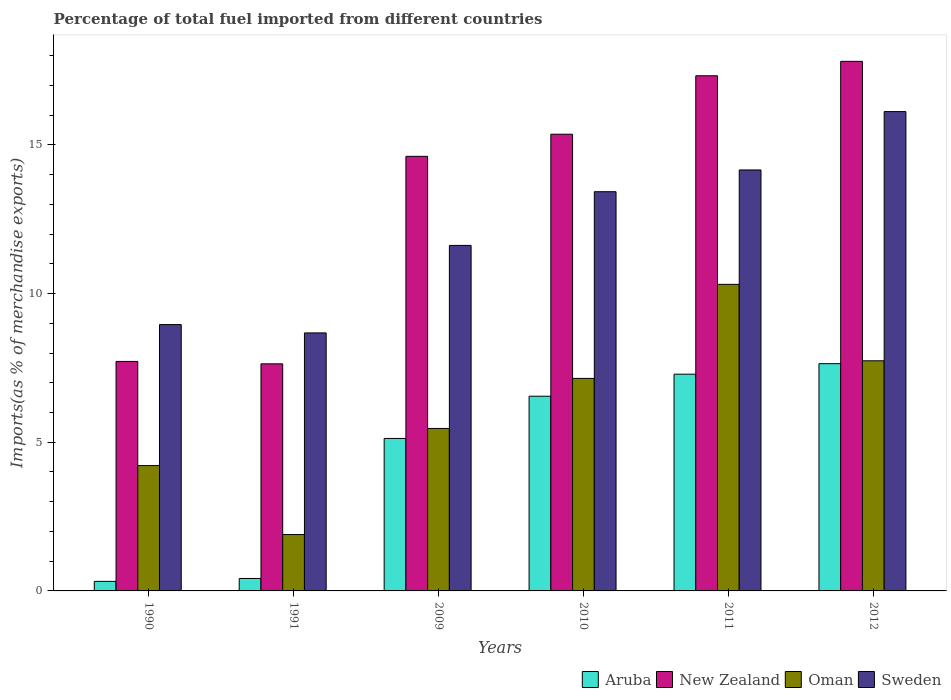Are the number of bars on each tick of the X-axis equal?
Your answer should be compact. Yes. What is the percentage of imports to different countries in Aruba in 1990?
Provide a short and direct response. 0.32. Across all years, what is the maximum percentage of imports to different countries in Sweden?
Give a very brief answer. 16.12. Across all years, what is the minimum percentage of imports to different countries in Oman?
Make the answer very short. 1.9. In which year was the percentage of imports to different countries in Oman maximum?
Provide a succinct answer. 2011. In which year was the percentage of imports to different countries in Oman minimum?
Provide a short and direct response. 1991. What is the total percentage of imports to different countries in Sweden in the graph?
Offer a very short reply. 72.95. What is the difference between the percentage of imports to different countries in Aruba in 1990 and that in 2009?
Your answer should be compact. -4.81. What is the difference between the percentage of imports to different countries in New Zealand in 2011 and the percentage of imports to different countries in Oman in 2010?
Offer a very short reply. 10.18. What is the average percentage of imports to different countries in Sweden per year?
Offer a very short reply. 12.16. In the year 2010, what is the difference between the percentage of imports to different countries in New Zealand and percentage of imports to different countries in Sweden?
Give a very brief answer. 1.93. In how many years, is the percentage of imports to different countries in Aruba greater than 5 %?
Provide a succinct answer. 4. What is the ratio of the percentage of imports to different countries in New Zealand in 1991 to that in 2009?
Your answer should be compact. 0.52. Is the percentage of imports to different countries in Oman in 1990 less than that in 2012?
Provide a succinct answer. Yes. Is the difference between the percentage of imports to different countries in New Zealand in 1990 and 2010 greater than the difference between the percentage of imports to different countries in Sweden in 1990 and 2010?
Your answer should be compact. No. What is the difference between the highest and the second highest percentage of imports to different countries in Oman?
Offer a very short reply. 2.57. What is the difference between the highest and the lowest percentage of imports to different countries in Oman?
Provide a short and direct response. 8.41. In how many years, is the percentage of imports to different countries in Aruba greater than the average percentage of imports to different countries in Aruba taken over all years?
Your answer should be very brief. 4. Is the sum of the percentage of imports to different countries in New Zealand in 2009 and 2010 greater than the maximum percentage of imports to different countries in Oman across all years?
Make the answer very short. Yes. Is it the case that in every year, the sum of the percentage of imports to different countries in New Zealand and percentage of imports to different countries in Aruba is greater than the sum of percentage of imports to different countries in Sweden and percentage of imports to different countries in Oman?
Ensure brevity in your answer.  No. What does the 4th bar from the left in 2011 represents?
Keep it short and to the point. Sweden. What does the 2nd bar from the right in 2010 represents?
Ensure brevity in your answer.  Oman. Are all the bars in the graph horizontal?
Offer a terse response. No. What is the difference between two consecutive major ticks on the Y-axis?
Make the answer very short. 5. Does the graph contain grids?
Ensure brevity in your answer.  No. What is the title of the graph?
Keep it short and to the point. Percentage of total fuel imported from different countries. What is the label or title of the Y-axis?
Your answer should be very brief. Imports(as % of merchandise exports). What is the Imports(as % of merchandise exports) in Aruba in 1990?
Offer a terse response. 0.32. What is the Imports(as % of merchandise exports) in New Zealand in 1990?
Provide a short and direct response. 7.72. What is the Imports(as % of merchandise exports) of Oman in 1990?
Give a very brief answer. 4.21. What is the Imports(as % of merchandise exports) of Sweden in 1990?
Make the answer very short. 8.96. What is the Imports(as % of merchandise exports) of Aruba in 1991?
Offer a terse response. 0.42. What is the Imports(as % of merchandise exports) of New Zealand in 1991?
Give a very brief answer. 7.64. What is the Imports(as % of merchandise exports) in Oman in 1991?
Your response must be concise. 1.9. What is the Imports(as % of merchandise exports) of Sweden in 1991?
Make the answer very short. 8.68. What is the Imports(as % of merchandise exports) of Aruba in 2009?
Your answer should be very brief. 5.13. What is the Imports(as % of merchandise exports) of New Zealand in 2009?
Keep it short and to the point. 14.61. What is the Imports(as % of merchandise exports) of Oman in 2009?
Your answer should be compact. 5.46. What is the Imports(as % of merchandise exports) of Sweden in 2009?
Ensure brevity in your answer.  11.62. What is the Imports(as % of merchandise exports) of Aruba in 2010?
Give a very brief answer. 6.55. What is the Imports(as % of merchandise exports) of New Zealand in 2010?
Your answer should be compact. 15.36. What is the Imports(as % of merchandise exports) of Oman in 2010?
Provide a short and direct response. 7.15. What is the Imports(as % of merchandise exports) of Sweden in 2010?
Ensure brevity in your answer.  13.42. What is the Imports(as % of merchandise exports) in Aruba in 2011?
Provide a succinct answer. 7.29. What is the Imports(as % of merchandise exports) of New Zealand in 2011?
Make the answer very short. 17.32. What is the Imports(as % of merchandise exports) of Oman in 2011?
Offer a terse response. 10.31. What is the Imports(as % of merchandise exports) in Sweden in 2011?
Your answer should be compact. 14.16. What is the Imports(as % of merchandise exports) in Aruba in 2012?
Ensure brevity in your answer.  7.64. What is the Imports(as % of merchandise exports) in New Zealand in 2012?
Offer a very short reply. 17.81. What is the Imports(as % of merchandise exports) of Oman in 2012?
Your answer should be very brief. 7.74. What is the Imports(as % of merchandise exports) of Sweden in 2012?
Provide a succinct answer. 16.12. Across all years, what is the maximum Imports(as % of merchandise exports) in Aruba?
Offer a very short reply. 7.64. Across all years, what is the maximum Imports(as % of merchandise exports) in New Zealand?
Ensure brevity in your answer.  17.81. Across all years, what is the maximum Imports(as % of merchandise exports) in Oman?
Offer a very short reply. 10.31. Across all years, what is the maximum Imports(as % of merchandise exports) of Sweden?
Ensure brevity in your answer.  16.12. Across all years, what is the minimum Imports(as % of merchandise exports) in Aruba?
Keep it short and to the point. 0.32. Across all years, what is the minimum Imports(as % of merchandise exports) in New Zealand?
Your answer should be compact. 7.64. Across all years, what is the minimum Imports(as % of merchandise exports) in Oman?
Offer a terse response. 1.9. Across all years, what is the minimum Imports(as % of merchandise exports) of Sweden?
Keep it short and to the point. 8.68. What is the total Imports(as % of merchandise exports) in Aruba in the graph?
Your response must be concise. 27.35. What is the total Imports(as % of merchandise exports) in New Zealand in the graph?
Offer a very short reply. 80.46. What is the total Imports(as % of merchandise exports) of Oman in the graph?
Keep it short and to the point. 36.77. What is the total Imports(as % of merchandise exports) of Sweden in the graph?
Your response must be concise. 72.95. What is the difference between the Imports(as % of merchandise exports) of Aruba in 1990 and that in 1991?
Provide a short and direct response. -0.1. What is the difference between the Imports(as % of merchandise exports) in New Zealand in 1990 and that in 1991?
Make the answer very short. 0.08. What is the difference between the Imports(as % of merchandise exports) of Oman in 1990 and that in 1991?
Offer a very short reply. 2.32. What is the difference between the Imports(as % of merchandise exports) in Sweden in 1990 and that in 1991?
Your response must be concise. 0.28. What is the difference between the Imports(as % of merchandise exports) in Aruba in 1990 and that in 2009?
Make the answer very short. -4.81. What is the difference between the Imports(as % of merchandise exports) in New Zealand in 1990 and that in 2009?
Offer a very short reply. -6.9. What is the difference between the Imports(as % of merchandise exports) of Oman in 1990 and that in 2009?
Ensure brevity in your answer.  -1.25. What is the difference between the Imports(as % of merchandise exports) in Sweden in 1990 and that in 2009?
Offer a terse response. -2.66. What is the difference between the Imports(as % of merchandise exports) of Aruba in 1990 and that in 2010?
Provide a succinct answer. -6.23. What is the difference between the Imports(as % of merchandise exports) in New Zealand in 1990 and that in 2010?
Offer a terse response. -7.64. What is the difference between the Imports(as % of merchandise exports) of Oman in 1990 and that in 2010?
Offer a terse response. -2.93. What is the difference between the Imports(as % of merchandise exports) of Sweden in 1990 and that in 2010?
Give a very brief answer. -4.47. What is the difference between the Imports(as % of merchandise exports) of Aruba in 1990 and that in 2011?
Provide a succinct answer. -6.97. What is the difference between the Imports(as % of merchandise exports) of New Zealand in 1990 and that in 2011?
Keep it short and to the point. -9.61. What is the difference between the Imports(as % of merchandise exports) of Oman in 1990 and that in 2011?
Your answer should be compact. -6.09. What is the difference between the Imports(as % of merchandise exports) in Sweden in 1990 and that in 2011?
Keep it short and to the point. -5.2. What is the difference between the Imports(as % of merchandise exports) of Aruba in 1990 and that in 2012?
Keep it short and to the point. -7.32. What is the difference between the Imports(as % of merchandise exports) of New Zealand in 1990 and that in 2012?
Keep it short and to the point. -10.09. What is the difference between the Imports(as % of merchandise exports) in Oman in 1990 and that in 2012?
Your answer should be compact. -3.52. What is the difference between the Imports(as % of merchandise exports) in Sweden in 1990 and that in 2012?
Give a very brief answer. -7.16. What is the difference between the Imports(as % of merchandise exports) in Aruba in 1991 and that in 2009?
Offer a terse response. -4.71. What is the difference between the Imports(as % of merchandise exports) of New Zealand in 1991 and that in 2009?
Provide a short and direct response. -6.98. What is the difference between the Imports(as % of merchandise exports) in Oman in 1991 and that in 2009?
Your answer should be compact. -3.57. What is the difference between the Imports(as % of merchandise exports) of Sweden in 1991 and that in 2009?
Provide a short and direct response. -2.94. What is the difference between the Imports(as % of merchandise exports) in Aruba in 1991 and that in 2010?
Make the answer very short. -6.13. What is the difference between the Imports(as % of merchandise exports) in New Zealand in 1991 and that in 2010?
Offer a very short reply. -7.72. What is the difference between the Imports(as % of merchandise exports) of Oman in 1991 and that in 2010?
Make the answer very short. -5.25. What is the difference between the Imports(as % of merchandise exports) in Sweden in 1991 and that in 2010?
Offer a terse response. -4.75. What is the difference between the Imports(as % of merchandise exports) in Aruba in 1991 and that in 2011?
Your response must be concise. -6.87. What is the difference between the Imports(as % of merchandise exports) in New Zealand in 1991 and that in 2011?
Offer a terse response. -9.69. What is the difference between the Imports(as % of merchandise exports) of Oman in 1991 and that in 2011?
Your answer should be compact. -8.41. What is the difference between the Imports(as % of merchandise exports) in Sweden in 1991 and that in 2011?
Give a very brief answer. -5.48. What is the difference between the Imports(as % of merchandise exports) in Aruba in 1991 and that in 2012?
Offer a very short reply. -7.22. What is the difference between the Imports(as % of merchandise exports) of New Zealand in 1991 and that in 2012?
Keep it short and to the point. -10.17. What is the difference between the Imports(as % of merchandise exports) of Oman in 1991 and that in 2012?
Your answer should be very brief. -5.84. What is the difference between the Imports(as % of merchandise exports) in Sweden in 1991 and that in 2012?
Offer a very short reply. -7.44. What is the difference between the Imports(as % of merchandise exports) in Aruba in 2009 and that in 2010?
Keep it short and to the point. -1.42. What is the difference between the Imports(as % of merchandise exports) in New Zealand in 2009 and that in 2010?
Your answer should be very brief. -0.74. What is the difference between the Imports(as % of merchandise exports) of Oman in 2009 and that in 2010?
Your answer should be compact. -1.68. What is the difference between the Imports(as % of merchandise exports) in Sweden in 2009 and that in 2010?
Keep it short and to the point. -1.81. What is the difference between the Imports(as % of merchandise exports) in Aruba in 2009 and that in 2011?
Ensure brevity in your answer.  -2.16. What is the difference between the Imports(as % of merchandise exports) of New Zealand in 2009 and that in 2011?
Provide a short and direct response. -2.71. What is the difference between the Imports(as % of merchandise exports) of Oman in 2009 and that in 2011?
Give a very brief answer. -4.85. What is the difference between the Imports(as % of merchandise exports) of Sweden in 2009 and that in 2011?
Ensure brevity in your answer.  -2.54. What is the difference between the Imports(as % of merchandise exports) of Aruba in 2009 and that in 2012?
Your answer should be very brief. -2.51. What is the difference between the Imports(as % of merchandise exports) in New Zealand in 2009 and that in 2012?
Give a very brief answer. -3.19. What is the difference between the Imports(as % of merchandise exports) of Oman in 2009 and that in 2012?
Offer a very short reply. -2.28. What is the difference between the Imports(as % of merchandise exports) in Sweden in 2009 and that in 2012?
Provide a short and direct response. -4.5. What is the difference between the Imports(as % of merchandise exports) in Aruba in 2010 and that in 2011?
Give a very brief answer. -0.74. What is the difference between the Imports(as % of merchandise exports) of New Zealand in 2010 and that in 2011?
Your response must be concise. -1.97. What is the difference between the Imports(as % of merchandise exports) of Oman in 2010 and that in 2011?
Your answer should be very brief. -3.16. What is the difference between the Imports(as % of merchandise exports) in Sweden in 2010 and that in 2011?
Provide a short and direct response. -0.73. What is the difference between the Imports(as % of merchandise exports) in Aruba in 2010 and that in 2012?
Keep it short and to the point. -1.09. What is the difference between the Imports(as % of merchandise exports) in New Zealand in 2010 and that in 2012?
Ensure brevity in your answer.  -2.45. What is the difference between the Imports(as % of merchandise exports) of Oman in 2010 and that in 2012?
Ensure brevity in your answer.  -0.59. What is the difference between the Imports(as % of merchandise exports) in Sweden in 2010 and that in 2012?
Your answer should be compact. -2.69. What is the difference between the Imports(as % of merchandise exports) in Aruba in 2011 and that in 2012?
Provide a short and direct response. -0.35. What is the difference between the Imports(as % of merchandise exports) of New Zealand in 2011 and that in 2012?
Offer a very short reply. -0.48. What is the difference between the Imports(as % of merchandise exports) of Oman in 2011 and that in 2012?
Your response must be concise. 2.57. What is the difference between the Imports(as % of merchandise exports) of Sweden in 2011 and that in 2012?
Provide a succinct answer. -1.96. What is the difference between the Imports(as % of merchandise exports) in Aruba in 1990 and the Imports(as % of merchandise exports) in New Zealand in 1991?
Your answer should be compact. -7.31. What is the difference between the Imports(as % of merchandise exports) in Aruba in 1990 and the Imports(as % of merchandise exports) in Oman in 1991?
Offer a very short reply. -1.57. What is the difference between the Imports(as % of merchandise exports) in Aruba in 1990 and the Imports(as % of merchandise exports) in Sweden in 1991?
Provide a short and direct response. -8.35. What is the difference between the Imports(as % of merchandise exports) of New Zealand in 1990 and the Imports(as % of merchandise exports) of Oman in 1991?
Your response must be concise. 5.82. What is the difference between the Imports(as % of merchandise exports) in New Zealand in 1990 and the Imports(as % of merchandise exports) in Sweden in 1991?
Your response must be concise. -0.96. What is the difference between the Imports(as % of merchandise exports) of Oman in 1990 and the Imports(as % of merchandise exports) of Sweden in 1991?
Ensure brevity in your answer.  -4.46. What is the difference between the Imports(as % of merchandise exports) in Aruba in 1990 and the Imports(as % of merchandise exports) in New Zealand in 2009?
Keep it short and to the point. -14.29. What is the difference between the Imports(as % of merchandise exports) in Aruba in 1990 and the Imports(as % of merchandise exports) in Oman in 2009?
Your answer should be compact. -5.14. What is the difference between the Imports(as % of merchandise exports) of Aruba in 1990 and the Imports(as % of merchandise exports) of Sweden in 2009?
Provide a succinct answer. -11.3. What is the difference between the Imports(as % of merchandise exports) in New Zealand in 1990 and the Imports(as % of merchandise exports) in Oman in 2009?
Provide a succinct answer. 2.25. What is the difference between the Imports(as % of merchandise exports) in New Zealand in 1990 and the Imports(as % of merchandise exports) in Sweden in 2009?
Provide a short and direct response. -3.9. What is the difference between the Imports(as % of merchandise exports) in Oman in 1990 and the Imports(as % of merchandise exports) in Sweden in 2009?
Ensure brevity in your answer.  -7.4. What is the difference between the Imports(as % of merchandise exports) of Aruba in 1990 and the Imports(as % of merchandise exports) of New Zealand in 2010?
Offer a terse response. -15.04. What is the difference between the Imports(as % of merchandise exports) of Aruba in 1990 and the Imports(as % of merchandise exports) of Oman in 2010?
Provide a succinct answer. -6.82. What is the difference between the Imports(as % of merchandise exports) of Aruba in 1990 and the Imports(as % of merchandise exports) of Sweden in 2010?
Your answer should be compact. -13.1. What is the difference between the Imports(as % of merchandise exports) of New Zealand in 1990 and the Imports(as % of merchandise exports) of Oman in 2010?
Keep it short and to the point. 0.57. What is the difference between the Imports(as % of merchandise exports) of New Zealand in 1990 and the Imports(as % of merchandise exports) of Sweden in 2010?
Give a very brief answer. -5.71. What is the difference between the Imports(as % of merchandise exports) of Oman in 1990 and the Imports(as % of merchandise exports) of Sweden in 2010?
Offer a terse response. -9.21. What is the difference between the Imports(as % of merchandise exports) of Aruba in 1990 and the Imports(as % of merchandise exports) of New Zealand in 2011?
Ensure brevity in your answer.  -17. What is the difference between the Imports(as % of merchandise exports) of Aruba in 1990 and the Imports(as % of merchandise exports) of Oman in 2011?
Keep it short and to the point. -9.99. What is the difference between the Imports(as % of merchandise exports) in Aruba in 1990 and the Imports(as % of merchandise exports) in Sweden in 2011?
Provide a short and direct response. -13.83. What is the difference between the Imports(as % of merchandise exports) of New Zealand in 1990 and the Imports(as % of merchandise exports) of Oman in 2011?
Keep it short and to the point. -2.59. What is the difference between the Imports(as % of merchandise exports) in New Zealand in 1990 and the Imports(as % of merchandise exports) in Sweden in 2011?
Ensure brevity in your answer.  -6.44. What is the difference between the Imports(as % of merchandise exports) in Oman in 1990 and the Imports(as % of merchandise exports) in Sweden in 2011?
Your answer should be compact. -9.94. What is the difference between the Imports(as % of merchandise exports) of Aruba in 1990 and the Imports(as % of merchandise exports) of New Zealand in 2012?
Give a very brief answer. -17.49. What is the difference between the Imports(as % of merchandise exports) of Aruba in 1990 and the Imports(as % of merchandise exports) of Oman in 2012?
Ensure brevity in your answer.  -7.42. What is the difference between the Imports(as % of merchandise exports) in Aruba in 1990 and the Imports(as % of merchandise exports) in Sweden in 2012?
Keep it short and to the point. -15.8. What is the difference between the Imports(as % of merchandise exports) in New Zealand in 1990 and the Imports(as % of merchandise exports) in Oman in 2012?
Provide a short and direct response. -0.02. What is the difference between the Imports(as % of merchandise exports) in New Zealand in 1990 and the Imports(as % of merchandise exports) in Sweden in 2012?
Offer a very short reply. -8.4. What is the difference between the Imports(as % of merchandise exports) in Oman in 1990 and the Imports(as % of merchandise exports) in Sweden in 2012?
Your response must be concise. -11.9. What is the difference between the Imports(as % of merchandise exports) in Aruba in 1991 and the Imports(as % of merchandise exports) in New Zealand in 2009?
Your response must be concise. -14.2. What is the difference between the Imports(as % of merchandise exports) of Aruba in 1991 and the Imports(as % of merchandise exports) of Oman in 2009?
Ensure brevity in your answer.  -5.04. What is the difference between the Imports(as % of merchandise exports) of Aruba in 1991 and the Imports(as % of merchandise exports) of Sweden in 2009?
Your answer should be compact. -11.2. What is the difference between the Imports(as % of merchandise exports) in New Zealand in 1991 and the Imports(as % of merchandise exports) in Oman in 2009?
Your response must be concise. 2.17. What is the difference between the Imports(as % of merchandise exports) in New Zealand in 1991 and the Imports(as % of merchandise exports) in Sweden in 2009?
Ensure brevity in your answer.  -3.98. What is the difference between the Imports(as % of merchandise exports) of Oman in 1991 and the Imports(as % of merchandise exports) of Sweden in 2009?
Provide a short and direct response. -9.72. What is the difference between the Imports(as % of merchandise exports) in Aruba in 1991 and the Imports(as % of merchandise exports) in New Zealand in 2010?
Provide a short and direct response. -14.94. What is the difference between the Imports(as % of merchandise exports) of Aruba in 1991 and the Imports(as % of merchandise exports) of Oman in 2010?
Provide a short and direct response. -6.73. What is the difference between the Imports(as % of merchandise exports) of Aruba in 1991 and the Imports(as % of merchandise exports) of Sweden in 2010?
Your answer should be very brief. -13.01. What is the difference between the Imports(as % of merchandise exports) in New Zealand in 1991 and the Imports(as % of merchandise exports) in Oman in 2010?
Offer a very short reply. 0.49. What is the difference between the Imports(as % of merchandise exports) of New Zealand in 1991 and the Imports(as % of merchandise exports) of Sweden in 2010?
Make the answer very short. -5.79. What is the difference between the Imports(as % of merchandise exports) in Oman in 1991 and the Imports(as % of merchandise exports) in Sweden in 2010?
Your response must be concise. -11.53. What is the difference between the Imports(as % of merchandise exports) in Aruba in 1991 and the Imports(as % of merchandise exports) in New Zealand in 2011?
Ensure brevity in your answer.  -16.9. What is the difference between the Imports(as % of merchandise exports) in Aruba in 1991 and the Imports(as % of merchandise exports) in Oman in 2011?
Provide a short and direct response. -9.89. What is the difference between the Imports(as % of merchandise exports) in Aruba in 1991 and the Imports(as % of merchandise exports) in Sweden in 2011?
Make the answer very short. -13.74. What is the difference between the Imports(as % of merchandise exports) in New Zealand in 1991 and the Imports(as % of merchandise exports) in Oman in 2011?
Your response must be concise. -2.67. What is the difference between the Imports(as % of merchandise exports) of New Zealand in 1991 and the Imports(as % of merchandise exports) of Sweden in 2011?
Your answer should be compact. -6.52. What is the difference between the Imports(as % of merchandise exports) in Oman in 1991 and the Imports(as % of merchandise exports) in Sweden in 2011?
Make the answer very short. -12.26. What is the difference between the Imports(as % of merchandise exports) in Aruba in 1991 and the Imports(as % of merchandise exports) in New Zealand in 2012?
Your answer should be very brief. -17.39. What is the difference between the Imports(as % of merchandise exports) in Aruba in 1991 and the Imports(as % of merchandise exports) in Oman in 2012?
Provide a succinct answer. -7.32. What is the difference between the Imports(as % of merchandise exports) of Aruba in 1991 and the Imports(as % of merchandise exports) of Sweden in 2012?
Give a very brief answer. -15.7. What is the difference between the Imports(as % of merchandise exports) in New Zealand in 1991 and the Imports(as % of merchandise exports) in Oman in 2012?
Keep it short and to the point. -0.1. What is the difference between the Imports(as % of merchandise exports) of New Zealand in 1991 and the Imports(as % of merchandise exports) of Sweden in 2012?
Offer a terse response. -8.48. What is the difference between the Imports(as % of merchandise exports) in Oman in 1991 and the Imports(as % of merchandise exports) in Sweden in 2012?
Your answer should be compact. -14.22. What is the difference between the Imports(as % of merchandise exports) of Aruba in 2009 and the Imports(as % of merchandise exports) of New Zealand in 2010?
Provide a short and direct response. -10.23. What is the difference between the Imports(as % of merchandise exports) in Aruba in 2009 and the Imports(as % of merchandise exports) in Oman in 2010?
Offer a terse response. -2.02. What is the difference between the Imports(as % of merchandise exports) of Aruba in 2009 and the Imports(as % of merchandise exports) of Sweden in 2010?
Provide a succinct answer. -8.3. What is the difference between the Imports(as % of merchandise exports) in New Zealand in 2009 and the Imports(as % of merchandise exports) in Oman in 2010?
Keep it short and to the point. 7.47. What is the difference between the Imports(as % of merchandise exports) in New Zealand in 2009 and the Imports(as % of merchandise exports) in Sweden in 2010?
Offer a terse response. 1.19. What is the difference between the Imports(as % of merchandise exports) of Oman in 2009 and the Imports(as % of merchandise exports) of Sweden in 2010?
Offer a terse response. -7.96. What is the difference between the Imports(as % of merchandise exports) of Aruba in 2009 and the Imports(as % of merchandise exports) of New Zealand in 2011?
Offer a terse response. -12.2. What is the difference between the Imports(as % of merchandise exports) of Aruba in 2009 and the Imports(as % of merchandise exports) of Oman in 2011?
Provide a short and direct response. -5.18. What is the difference between the Imports(as % of merchandise exports) of Aruba in 2009 and the Imports(as % of merchandise exports) of Sweden in 2011?
Provide a succinct answer. -9.03. What is the difference between the Imports(as % of merchandise exports) in New Zealand in 2009 and the Imports(as % of merchandise exports) in Oman in 2011?
Offer a terse response. 4.3. What is the difference between the Imports(as % of merchandise exports) of New Zealand in 2009 and the Imports(as % of merchandise exports) of Sweden in 2011?
Your answer should be very brief. 0.46. What is the difference between the Imports(as % of merchandise exports) in Oman in 2009 and the Imports(as % of merchandise exports) in Sweden in 2011?
Make the answer very short. -8.69. What is the difference between the Imports(as % of merchandise exports) of Aruba in 2009 and the Imports(as % of merchandise exports) of New Zealand in 2012?
Your response must be concise. -12.68. What is the difference between the Imports(as % of merchandise exports) in Aruba in 2009 and the Imports(as % of merchandise exports) in Oman in 2012?
Provide a short and direct response. -2.61. What is the difference between the Imports(as % of merchandise exports) in Aruba in 2009 and the Imports(as % of merchandise exports) in Sweden in 2012?
Ensure brevity in your answer.  -10.99. What is the difference between the Imports(as % of merchandise exports) in New Zealand in 2009 and the Imports(as % of merchandise exports) in Oman in 2012?
Provide a short and direct response. 6.88. What is the difference between the Imports(as % of merchandise exports) of New Zealand in 2009 and the Imports(as % of merchandise exports) of Sweden in 2012?
Provide a short and direct response. -1.5. What is the difference between the Imports(as % of merchandise exports) of Oman in 2009 and the Imports(as % of merchandise exports) of Sweden in 2012?
Give a very brief answer. -10.66. What is the difference between the Imports(as % of merchandise exports) in Aruba in 2010 and the Imports(as % of merchandise exports) in New Zealand in 2011?
Offer a very short reply. -10.78. What is the difference between the Imports(as % of merchandise exports) in Aruba in 2010 and the Imports(as % of merchandise exports) in Oman in 2011?
Your response must be concise. -3.76. What is the difference between the Imports(as % of merchandise exports) in Aruba in 2010 and the Imports(as % of merchandise exports) in Sweden in 2011?
Ensure brevity in your answer.  -7.61. What is the difference between the Imports(as % of merchandise exports) in New Zealand in 2010 and the Imports(as % of merchandise exports) in Oman in 2011?
Your answer should be compact. 5.05. What is the difference between the Imports(as % of merchandise exports) of New Zealand in 2010 and the Imports(as % of merchandise exports) of Sweden in 2011?
Make the answer very short. 1.2. What is the difference between the Imports(as % of merchandise exports) of Oman in 2010 and the Imports(as % of merchandise exports) of Sweden in 2011?
Give a very brief answer. -7.01. What is the difference between the Imports(as % of merchandise exports) in Aruba in 2010 and the Imports(as % of merchandise exports) in New Zealand in 2012?
Give a very brief answer. -11.26. What is the difference between the Imports(as % of merchandise exports) in Aruba in 2010 and the Imports(as % of merchandise exports) in Oman in 2012?
Offer a terse response. -1.19. What is the difference between the Imports(as % of merchandise exports) in Aruba in 2010 and the Imports(as % of merchandise exports) in Sweden in 2012?
Give a very brief answer. -9.57. What is the difference between the Imports(as % of merchandise exports) of New Zealand in 2010 and the Imports(as % of merchandise exports) of Oman in 2012?
Keep it short and to the point. 7.62. What is the difference between the Imports(as % of merchandise exports) in New Zealand in 2010 and the Imports(as % of merchandise exports) in Sweden in 2012?
Offer a very short reply. -0.76. What is the difference between the Imports(as % of merchandise exports) of Oman in 2010 and the Imports(as % of merchandise exports) of Sweden in 2012?
Offer a terse response. -8.97. What is the difference between the Imports(as % of merchandise exports) in Aruba in 2011 and the Imports(as % of merchandise exports) in New Zealand in 2012?
Your answer should be compact. -10.52. What is the difference between the Imports(as % of merchandise exports) in Aruba in 2011 and the Imports(as % of merchandise exports) in Oman in 2012?
Your answer should be compact. -0.45. What is the difference between the Imports(as % of merchandise exports) of Aruba in 2011 and the Imports(as % of merchandise exports) of Sweden in 2012?
Provide a short and direct response. -8.83. What is the difference between the Imports(as % of merchandise exports) in New Zealand in 2011 and the Imports(as % of merchandise exports) in Oman in 2012?
Ensure brevity in your answer.  9.58. What is the difference between the Imports(as % of merchandise exports) in New Zealand in 2011 and the Imports(as % of merchandise exports) in Sweden in 2012?
Ensure brevity in your answer.  1.2. What is the difference between the Imports(as % of merchandise exports) in Oman in 2011 and the Imports(as % of merchandise exports) in Sweden in 2012?
Keep it short and to the point. -5.81. What is the average Imports(as % of merchandise exports) of Aruba per year?
Your answer should be very brief. 4.56. What is the average Imports(as % of merchandise exports) of New Zealand per year?
Ensure brevity in your answer.  13.41. What is the average Imports(as % of merchandise exports) of Oman per year?
Your answer should be very brief. 6.13. What is the average Imports(as % of merchandise exports) of Sweden per year?
Keep it short and to the point. 12.16. In the year 1990, what is the difference between the Imports(as % of merchandise exports) in Aruba and Imports(as % of merchandise exports) in New Zealand?
Ensure brevity in your answer.  -7.4. In the year 1990, what is the difference between the Imports(as % of merchandise exports) of Aruba and Imports(as % of merchandise exports) of Oman?
Make the answer very short. -3.89. In the year 1990, what is the difference between the Imports(as % of merchandise exports) of Aruba and Imports(as % of merchandise exports) of Sweden?
Keep it short and to the point. -8.63. In the year 1990, what is the difference between the Imports(as % of merchandise exports) of New Zealand and Imports(as % of merchandise exports) of Oman?
Provide a succinct answer. 3.5. In the year 1990, what is the difference between the Imports(as % of merchandise exports) of New Zealand and Imports(as % of merchandise exports) of Sweden?
Give a very brief answer. -1.24. In the year 1990, what is the difference between the Imports(as % of merchandise exports) of Oman and Imports(as % of merchandise exports) of Sweden?
Provide a succinct answer. -4.74. In the year 1991, what is the difference between the Imports(as % of merchandise exports) of Aruba and Imports(as % of merchandise exports) of New Zealand?
Give a very brief answer. -7.22. In the year 1991, what is the difference between the Imports(as % of merchandise exports) of Aruba and Imports(as % of merchandise exports) of Oman?
Offer a terse response. -1.48. In the year 1991, what is the difference between the Imports(as % of merchandise exports) in Aruba and Imports(as % of merchandise exports) in Sweden?
Make the answer very short. -8.26. In the year 1991, what is the difference between the Imports(as % of merchandise exports) of New Zealand and Imports(as % of merchandise exports) of Oman?
Make the answer very short. 5.74. In the year 1991, what is the difference between the Imports(as % of merchandise exports) of New Zealand and Imports(as % of merchandise exports) of Sweden?
Ensure brevity in your answer.  -1.04. In the year 1991, what is the difference between the Imports(as % of merchandise exports) of Oman and Imports(as % of merchandise exports) of Sweden?
Ensure brevity in your answer.  -6.78. In the year 2009, what is the difference between the Imports(as % of merchandise exports) in Aruba and Imports(as % of merchandise exports) in New Zealand?
Ensure brevity in your answer.  -9.49. In the year 2009, what is the difference between the Imports(as % of merchandise exports) in Aruba and Imports(as % of merchandise exports) in Oman?
Offer a very short reply. -0.34. In the year 2009, what is the difference between the Imports(as % of merchandise exports) in Aruba and Imports(as % of merchandise exports) in Sweden?
Provide a short and direct response. -6.49. In the year 2009, what is the difference between the Imports(as % of merchandise exports) in New Zealand and Imports(as % of merchandise exports) in Oman?
Provide a short and direct response. 9.15. In the year 2009, what is the difference between the Imports(as % of merchandise exports) in New Zealand and Imports(as % of merchandise exports) in Sweden?
Keep it short and to the point. 3. In the year 2009, what is the difference between the Imports(as % of merchandise exports) of Oman and Imports(as % of merchandise exports) of Sweden?
Your answer should be compact. -6.16. In the year 2010, what is the difference between the Imports(as % of merchandise exports) of Aruba and Imports(as % of merchandise exports) of New Zealand?
Offer a very short reply. -8.81. In the year 2010, what is the difference between the Imports(as % of merchandise exports) in Aruba and Imports(as % of merchandise exports) in Oman?
Give a very brief answer. -0.6. In the year 2010, what is the difference between the Imports(as % of merchandise exports) in Aruba and Imports(as % of merchandise exports) in Sweden?
Your response must be concise. -6.88. In the year 2010, what is the difference between the Imports(as % of merchandise exports) of New Zealand and Imports(as % of merchandise exports) of Oman?
Provide a succinct answer. 8.21. In the year 2010, what is the difference between the Imports(as % of merchandise exports) of New Zealand and Imports(as % of merchandise exports) of Sweden?
Your answer should be very brief. 1.93. In the year 2010, what is the difference between the Imports(as % of merchandise exports) in Oman and Imports(as % of merchandise exports) in Sweden?
Provide a short and direct response. -6.28. In the year 2011, what is the difference between the Imports(as % of merchandise exports) of Aruba and Imports(as % of merchandise exports) of New Zealand?
Ensure brevity in your answer.  -10.03. In the year 2011, what is the difference between the Imports(as % of merchandise exports) in Aruba and Imports(as % of merchandise exports) in Oman?
Offer a terse response. -3.02. In the year 2011, what is the difference between the Imports(as % of merchandise exports) of Aruba and Imports(as % of merchandise exports) of Sweden?
Your response must be concise. -6.87. In the year 2011, what is the difference between the Imports(as % of merchandise exports) of New Zealand and Imports(as % of merchandise exports) of Oman?
Offer a terse response. 7.01. In the year 2011, what is the difference between the Imports(as % of merchandise exports) of New Zealand and Imports(as % of merchandise exports) of Sweden?
Ensure brevity in your answer.  3.17. In the year 2011, what is the difference between the Imports(as % of merchandise exports) of Oman and Imports(as % of merchandise exports) of Sweden?
Your answer should be very brief. -3.85. In the year 2012, what is the difference between the Imports(as % of merchandise exports) of Aruba and Imports(as % of merchandise exports) of New Zealand?
Your response must be concise. -10.17. In the year 2012, what is the difference between the Imports(as % of merchandise exports) of Aruba and Imports(as % of merchandise exports) of Oman?
Ensure brevity in your answer.  -0.1. In the year 2012, what is the difference between the Imports(as % of merchandise exports) in Aruba and Imports(as % of merchandise exports) in Sweden?
Offer a terse response. -8.48. In the year 2012, what is the difference between the Imports(as % of merchandise exports) of New Zealand and Imports(as % of merchandise exports) of Oman?
Provide a short and direct response. 10.07. In the year 2012, what is the difference between the Imports(as % of merchandise exports) of New Zealand and Imports(as % of merchandise exports) of Sweden?
Provide a succinct answer. 1.69. In the year 2012, what is the difference between the Imports(as % of merchandise exports) of Oman and Imports(as % of merchandise exports) of Sweden?
Offer a very short reply. -8.38. What is the ratio of the Imports(as % of merchandise exports) in Aruba in 1990 to that in 1991?
Your response must be concise. 0.77. What is the ratio of the Imports(as % of merchandise exports) of New Zealand in 1990 to that in 1991?
Keep it short and to the point. 1.01. What is the ratio of the Imports(as % of merchandise exports) in Oman in 1990 to that in 1991?
Your answer should be very brief. 2.22. What is the ratio of the Imports(as % of merchandise exports) in Sweden in 1990 to that in 1991?
Your response must be concise. 1.03. What is the ratio of the Imports(as % of merchandise exports) of Aruba in 1990 to that in 2009?
Your answer should be compact. 0.06. What is the ratio of the Imports(as % of merchandise exports) of New Zealand in 1990 to that in 2009?
Your answer should be compact. 0.53. What is the ratio of the Imports(as % of merchandise exports) in Oman in 1990 to that in 2009?
Offer a terse response. 0.77. What is the ratio of the Imports(as % of merchandise exports) of Sweden in 1990 to that in 2009?
Ensure brevity in your answer.  0.77. What is the ratio of the Imports(as % of merchandise exports) of Aruba in 1990 to that in 2010?
Give a very brief answer. 0.05. What is the ratio of the Imports(as % of merchandise exports) in New Zealand in 1990 to that in 2010?
Your response must be concise. 0.5. What is the ratio of the Imports(as % of merchandise exports) in Oman in 1990 to that in 2010?
Provide a succinct answer. 0.59. What is the ratio of the Imports(as % of merchandise exports) of Sweden in 1990 to that in 2010?
Provide a succinct answer. 0.67. What is the ratio of the Imports(as % of merchandise exports) in Aruba in 1990 to that in 2011?
Ensure brevity in your answer.  0.04. What is the ratio of the Imports(as % of merchandise exports) of New Zealand in 1990 to that in 2011?
Offer a terse response. 0.45. What is the ratio of the Imports(as % of merchandise exports) of Oman in 1990 to that in 2011?
Offer a very short reply. 0.41. What is the ratio of the Imports(as % of merchandise exports) of Sweden in 1990 to that in 2011?
Your response must be concise. 0.63. What is the ratio of the Imports(as % of merchandise exports) of Aruba in 1990 to that in 2012?
Ensure brevity in your answer.  0.04. What is the ratio of the Imports(as % of merchandise exports) in New Zealand in 1990 to that in 2012?
Offer a terse response. 0.43. What is the ratio of the Imports(as % of merchandise exports) in Oman in 1990 to that in 2012?
Make the answer very short. 0.54. What is the ratio of the Imports(as % of merchandise exports) of Sweden in 1990 to that in 2012?
Give a very brief answer. 0.56. What is the ratio of the Imports(as % of merchandise exports) in Aruba in 1991 to that in 2009?
Offer a very short reply. 0.08. What is the ratio of the Imports(as % of merchandise exports) in New Zealand in 1991 to that in 2009?
Your answer should be compact. 0.52. What is the ratio of the Imports(as % of merchandise exports) in Oman in 1991 to that in 2009?
Your response must be concise. 0.35. What is the ratio of the Imports(as % of merchandise exports) in Sweden in 1991 to that in 2009?
Give a very brief answer. 0.75. What is the ratio of the Imports(as % of merchandise exports) in Aruba in 1991 to that in 2010?
Offer a very short reply. 0.06. What is the ratio of the Imports(as % of merchandise exports) in New Zealand in 1991 to that in 2010?
Give a very brief answer. 0.5. What is the ratio of the Imports(as % of merchandise exports) in Oman in 1991 to that in 2010?
Offer a very short reply. 0.27. What is the ratio of the Imports(as % of merchandise exports) in Sweden in 1991 to that in 2010?
Your answer should be very brief. 0.65. What is the ratio of the Imports(as % of merchandise exports) in Aruba in 1991 to that in 2011?
Your response must be concise. 0.06. What is the ratio of the Imports(as % of merchandise exports) in New Zealand in 1991 to that in 2011?
Offer a very short reply. 0.44. What is the ratio of the Imports(as % of merchandise exports) of Oman in 1991 to that in 2011?
Provide a short and direct response. 0.18. What is the ratio of the Imports(as % of merchandise exports) in Sweden in 1991 to that in 2011?
Keep it short and to the point. 0.61. What is the ratio of the Imports(as % of merchandise exports) in Aruba in 1991 to that in 2012?
Ensure brevity in your answer.  0.05. What is the ratio of the Imports(as % of merchandise exports) of New Zealand in 1991 to that in 2012?
Your answer should be very brief. 0.43. What is the ratio of the Imports(as % of merchandise exports) of Oman in 1991 to that in 2012?
Make the answer very short. 0.24. What is the ratio of the Imports(as % of merchandise exports) of Sweden in 1991 to that in 2012?
Your answer should be compact. 0.54. What is the ratio of the Imports(as % of merchandise exports) of Aruba in 2009 to that in 2010?
Provide a short and direct response. 0.78. What is the ratio of the Imports(as % of merchandise exports) in New Zealand in 2009 to that in 2010?
Keep it short and to the point. 0.95. What is the ratio of the Imports(as % of merchandise exports) in Oman in 2009 to that in 2010?
Give a very brief answer. 0.76. What is the ratio of the Imports(as % of merchandise exports) in Sweden in 2009 to that in 2010?
Offer a terse response. 0.87. What is the ratio of the Imports(as % of merchandise exports) in Aruba in 2009 to that in 2011?
Make the answer very short. 0.7. What is the ratio of the Imports(as % of merchandise exports) in New Zealand in 2009 to that in 2011?
Make the answer very short. 0.84. What is the ratio of the Imports(as % of merchandise exports) in Oman in 2009 to that in 2011?
Make the answer very short. 0.53. What is the ratio of the Imports(as % of merchandise exports) in Sweden in 2009 to that in 2011?
Your answer should be very brief. 0.82. What is the ratio of the Imports(as % of merchandise exports) of Aruba in 2009 to that in 2012?
Offer a very short reply. 0.67. What is the ratio of the Imports(as % of merchandise exports) in New Zealand in 2009 to that in 2012?
Your answer should be very brief. 0.82. What is the ratio of the Imports(as % of merchandise exports) in Oman in 2009 to that in 2012?
Keep it short and to the point. 0.71. What is the ratio of the Imports(as % of merchandise exports) of Sweden in 2009 to that in 2012?
Ensure brevity in your answer.  0.72. What is the ratio of the Imports(as % of merchandise exports) of Aruba in 2010 to that in 2011?
Ensure brevity in your answer.  0.9. What is the ratio of the Imports(as % of merchandise exports) of New Zealand in 2010 to that in 2011?
Offer a terse response. 0.89. What is the ratio of the Imports(as % of merchandise exports) of Oman in 2010 to that in 2011?
Keep it short and to the point. 0.69. What is the ratio of the Imports(as % of merchandise exports) of Sweden in 2010 to that in 2011?
Offer a very short reply. 0.95. What is the ratio of the Imports(as % of merchandise exports) in Aruba in 2010 to that in 2012?
Provide a short and direct response. 0.86. What is the ratio of the Imports(as % of merchandise exports) of New Zealand in 2010 to that in 2012?
Ensure brevity in your answer.  0.86. What is the ratio of the Imports(as % of merchandise exports) of Oman in 2010 to that in 2012?
Provide a succinct answer. 0.92. What is the ratio of the Imports(as % of merchandise exports) of Sweden in 2010 to that in 2012?
Keep it short and to the point. 0.83. What is the ratio of the Imports(as % of merchandise exports) of Aruba in 2011 to that in 2012?
Offer a terse response. 0.95. What is the ratio of the Imports(as % of merchandise exports) in New Zealand in 2011 to that in 2012?
Ensure brevity in your answer.  0.97. What is the ratio of the Imports(as % of merchandise exports) in Oman in 2011 to that in 2012?
Give a very brief answer. 1.33. What is the ratio of the Imports(as % of merchandise exports) of Sweden in 2011 to that in 2012?
Give a very brief answer. 0.88. What is the difference between the highest and the second highest Imports(as % of merchandise exports) in Aruba?
Offer a terse response. 0.35. What is the difference between the highest and the second highest Imports(as % of merchandise exports) in New Zealand?
Offer a very short reply. 0.48. What is the difference between the highest and the second highest Imports(as % of merchandise exports) in Oman?
Provide a short and direct response. 2.57. What is the difference between the highest and the second highest Imports(as % of merchandise exports) in Sweden?
Give a very brief answer. 1.96. What is the difference between the highest and the lowest Imports(as % of merchandise exports) in Aruba?
Your answer should be very brief. 7.32. What is the difference between the highest and the lowest Imports(as % of merchandise exports) in New Zealand?
Make the answer very short. 10.17. What is the difference between the highest and the lowest Imports(as % of merchandise exports) of Oman?
Offer a very short reply. 8.41. What is the difference between the highest and the lowest Imports(as % of merchandise exports) in Sweden?
Your response must be concise. 7.44. 